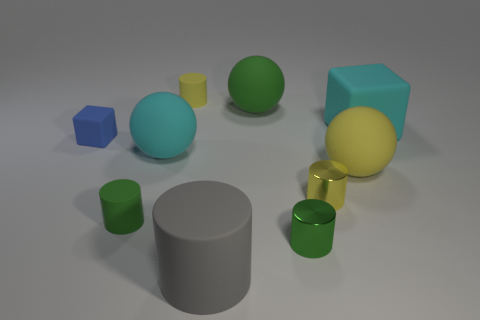Are there any big green spheres in front of the large cyan object that is in front of the tiny blue rubber cube?
Your response must be concise. No. How many things are things left of the large cube or tiny cylinders?
Give a very brief answer. 9. Are there any other things that are the same size as the yellow sphere?
Keep it short and to the point. Yes. What is the material of the block to the left of the cyan thing behind the small block?
Your answer should be very brief. Rubber. Are there the same number of large green matte spheres to the right of the tiny green metallic object and large cylinders that are to the left of the big yellow rubber thing?
Provide a succinct answer. No. How many objects are matte objects left of the green rubber sphere or objects to the left of the cyan rubber ball?
Your response must be concise. 5. There is a small thing that is left of the green sphere and in front of the big yellow object; what is its material?
Make the answer very short. Rubber. What size is the rubber cylinder that is on the left side of the tiny yellow cylinder that is behind the small blue cube that is to the left of the cyan rubber cube?
Keep it short and to the point. Small. Is the number of gray things greater than the number of yellow rubber things?
Offer a very short reply. No. Is the big thing that is to the left of the gray matte cylinder made of the same material as the tiny blue cube?
Offer a very short reply. Yes. 